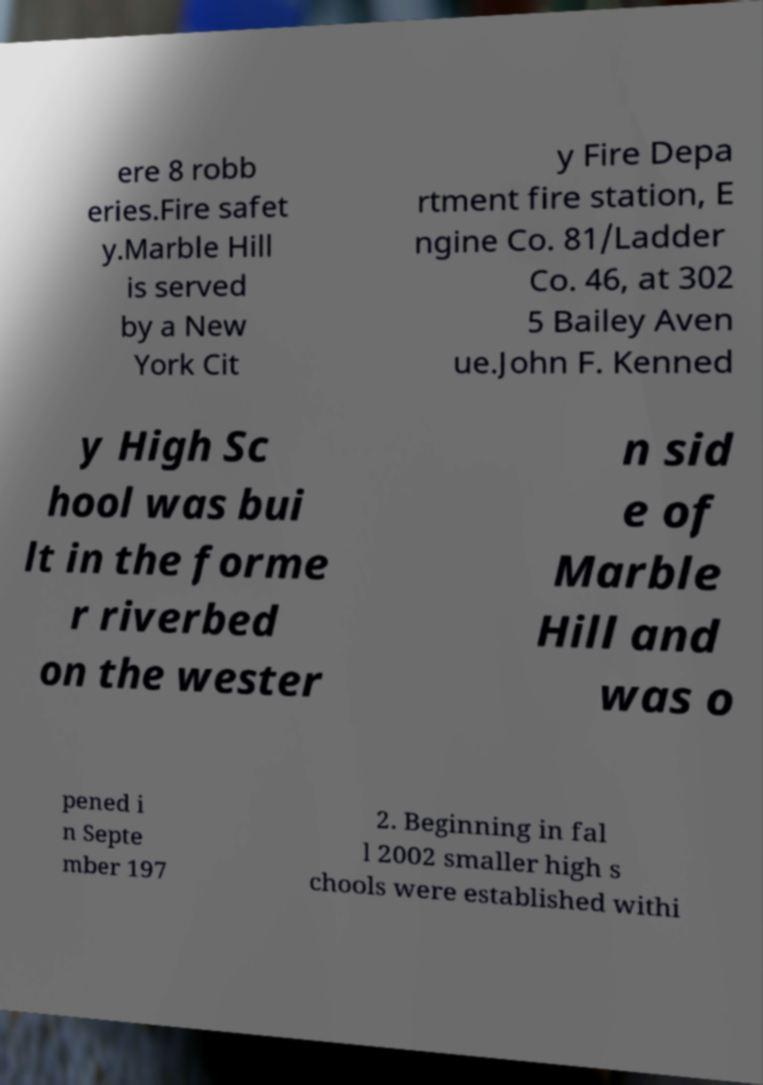Please identify and transcribe the text found in this image. ere 8 robb eries.Fire safet y.Marble Hill is served by a New York Cit y Fire Depa rtment fire station, E ngine Co. 81/Ladder Co. 46, at 302 5 Bailey Aven ue.John F. Kenned y High Sc hool was bui lt in the forme r riverbed on the wester n sid e of Marble Hill and was o pened i n Septe mber 197 2. Beginning in fal l 2002 smaller high s chools were established withi 